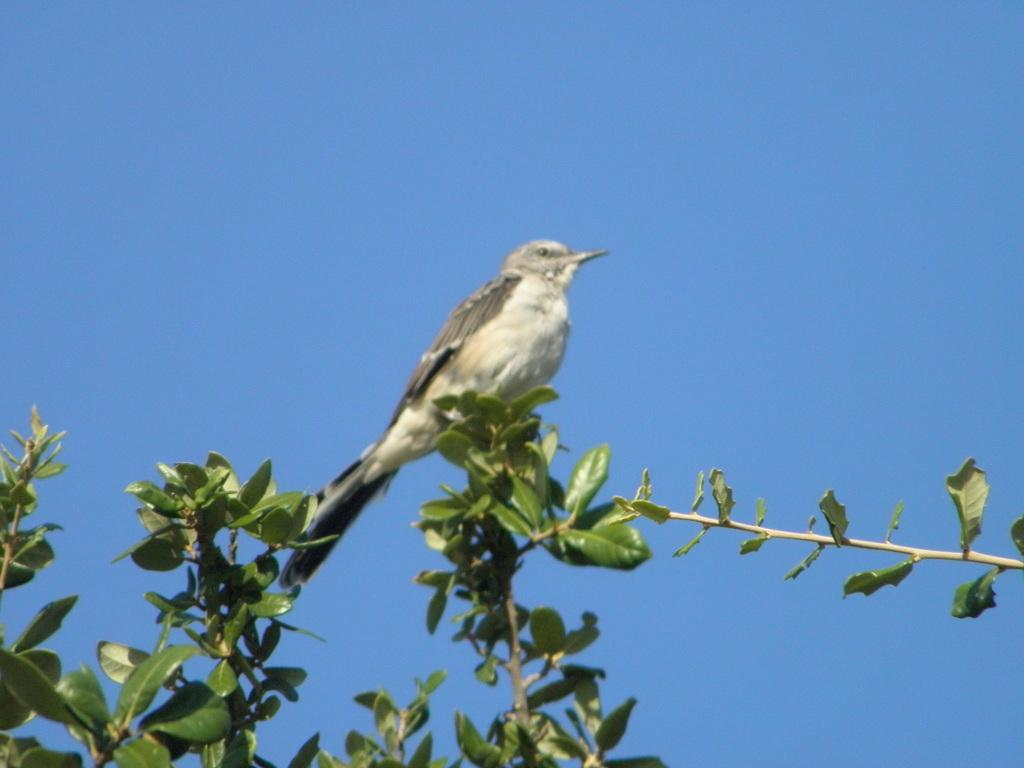What type of animal can be seen in the picture? There is a bird in the picture. What else is present at the bottom of the picture? There are plants at the bottom of the picture. What color is the sky in the background of the picture? The sky is blue in the background of the picture. What type of honey is the bird collecting in the picture? There is no honey present in the picture, and the bird is not collecting anything. 